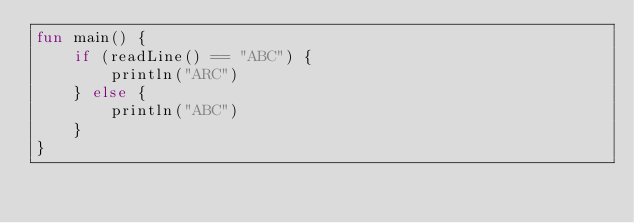Convert code to text. <code><loc_0><loc_0><loc_500><loc_500><_Kotlin_>fun main() {
    if (readLine() == "ABC") {
        println("ARC")
    } else {
        println("ABC")
    }
}</code> 